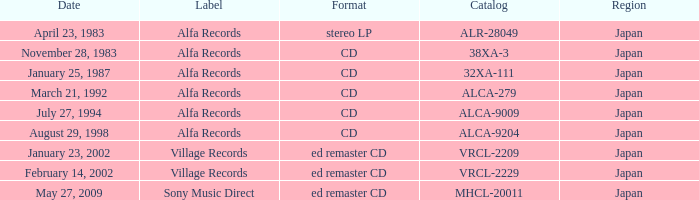What is the format of the date February 14, 2002? Ed remaster cd. Can you parse all the data within this table? {'header': ['Date', 'Label', 'Format', 'Catalog', 'Region'], 'rows': [['April 23, 1983', 'Alfa Records', 'stereo LP', 'ALR-28049', 'Japan'], ['November 28, 1983', 'Alfa Records', 'CD', '38XA-3', 'Japan'], ['January 25, 1987', 'Alfa Records', 'CD', '32XA-111', 'Japan'], ['March 21, 1992', 'Alfa Records', 'CD', 'ALCA-279', 'Japan'], ['July 27, 1994', 'Alfa Records', 'CD', 'ALCA-9009', 'Japan'], ['August 29, 1998', 'Alfa Records', 'CD', 'ALCA-9204', 'Japan'], ['January 23, 2002', 'Village Records', 'ed remaster CD', 'VRCL-2209', 'Japan'], ['February 14, 2002', 'Village Records', 'ed remaster CD', 'VRCL-2229', 'Japan'], ['May 27, 2009', 'Sony Music Direct', 'ed remaster CD', 'MHCL-20011', 'Japan']]} 